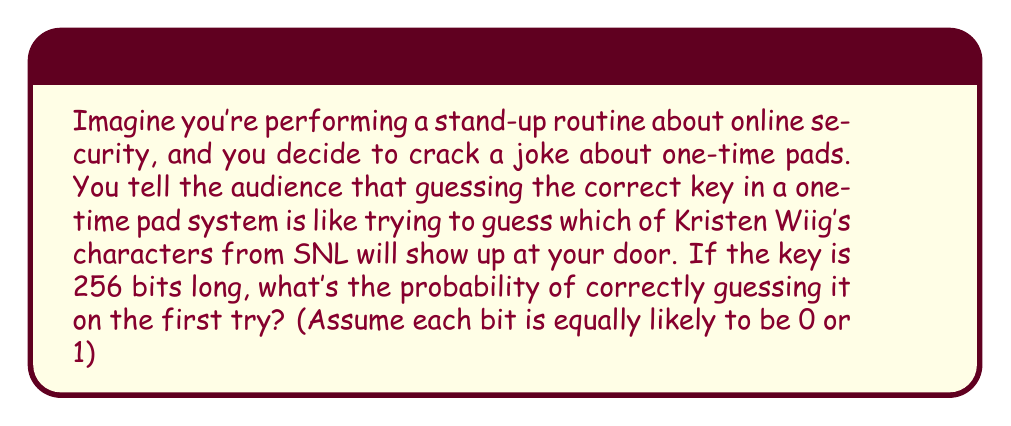Solve this math problem. Let's break this down step-by-step:

1) In a one-time pad system, each bit of the key is randomly chosen to be either 0 or 1.

2) For each bit, the probability of guessing correctly is $\frac{1}{2}$ or 0.5.

3) We need to guess all 256 bits correctly to guess the entire key.

4) The probability of independent events occurring together is the product of their individual probabilities.

5) Therefore, the probability of guessing all 256 bits correctly is:

   $$P(\text{correct guess}) = (\frac{1}{2})^{256}$$

6) We can simplify this:

   $$P(\text{correct guess}) = \frac{1}{2^{256}}$$

7) To put this in perspective, this is approximately equal to:

   $$\frac{1}{1.1579 \times 10^{77}}$$

This is an incredibly small number, even smaller than the probability of Kristen Wiig's character Gilly showing up at your door and actually being well-behaved!
Answer: $\frac{1}{2^{256}}$ 